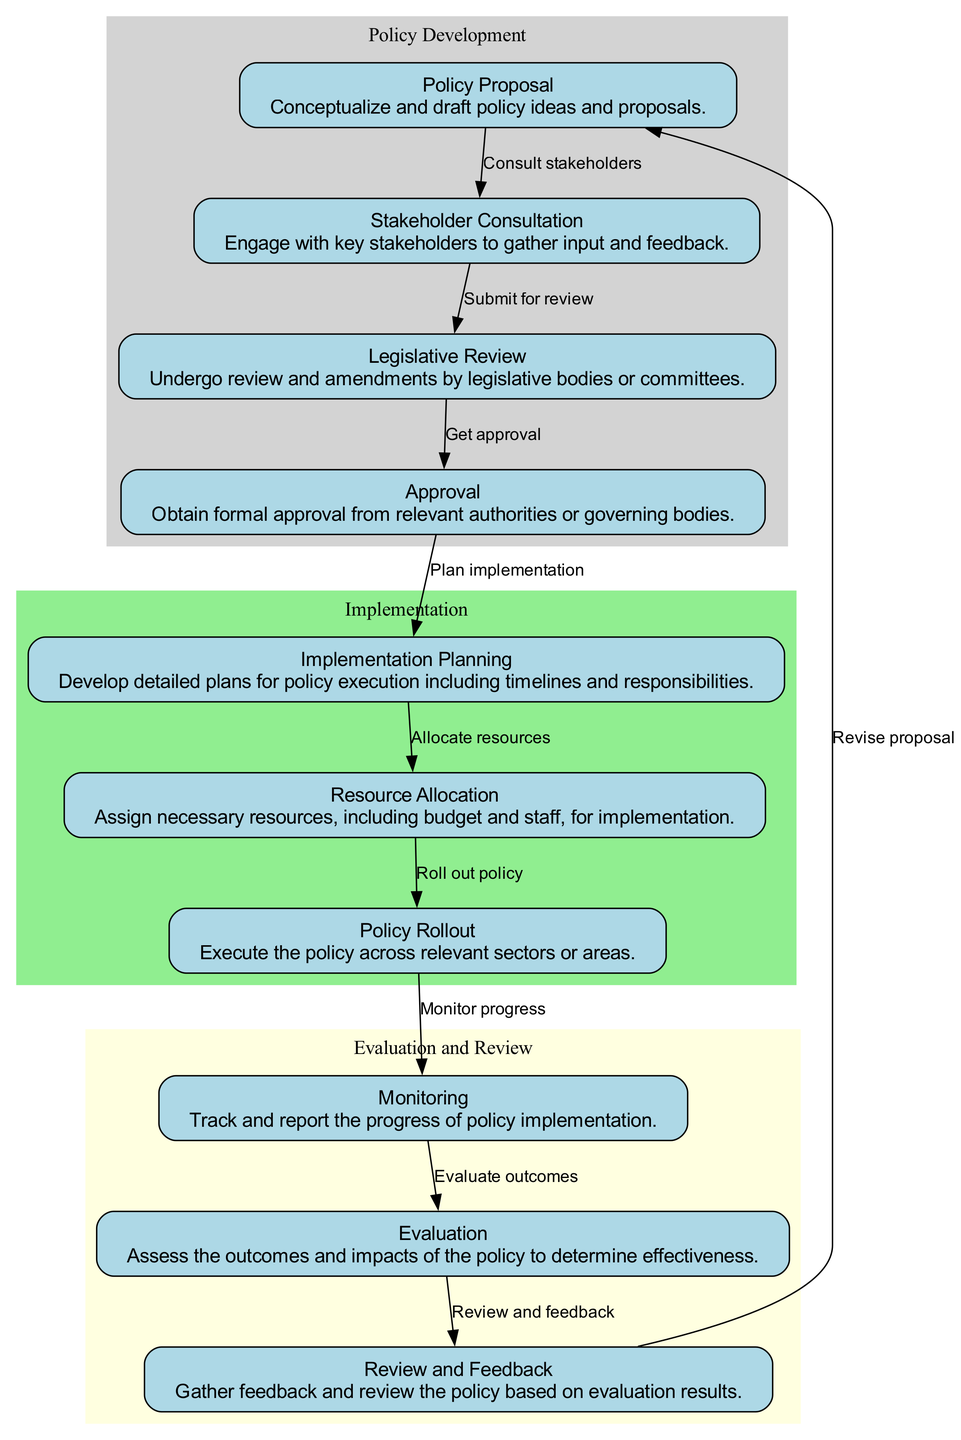What is the first step in the policy lifecycle? The first step in the policy lifecycle is represented by the node labeled "Policy Proposal." This is the starting point where policy ideas are created.
Answer: Policy Proposal How many nodes are in the diagram? The diagram includes a total of 10 nodes, each representing a different stage in the policy lifecycle from proposal to evaluation.
Answer: 10 What connects "Legislative Review" to "Approval"? "Legislative Review" is connected to "Approval" by an edge labeled "Get approval," indicating that following legislative review, formal approval is sought.
Answer: Get approval Which step comes after "Resource Allocation"? The step that follows "Resource Allocation" is "Policy Rollout," indicating that after resources are allocated, the policy is executed.
Answer: Policy Rollout What two nodes are connected by the edge labeled "Submit for review"? The edge labeled "Submit for review" connects the nodes "Stakeholder Consultation" and "Legislative Review," indicating the submission of the policy proposal for legislative examination.
Answer: Stakeholder Consultation and Legislative Review What phase includes both "Monitoring" and "Evaluation"? Both "Monitoring" and "Evaluation" are part of the "Evaluation and Review" phase, which focuses on assessing the policy's effectiveness.
Answer: Evaluation and Review How many edges are there in the diagram? There are a total of 9 edges that connect the different nodes in the policy lifecycle, representing the flow from one step to another.
Answer: 9 Which node comes before "Implementation Planning"? The node that comes before "Implementation Planning" is "Approval," indicating that formal approval must be obtained before planning for implementation can start.
Answer: Approval What is the relationship between "Review and Feedback" and "Policy Proposal"? "Review and Feedback" is connected back to "Policy Proposal" by the edge labeled "Revise proposal," indicating an iterative process where feedback leads to proposal revisions.
Answer: Revise proposal What is the last step in the policy lifecycle? The last step in the policy lifecycle is "Review and Feedback," where the policy is reviewed based on its evaluation results.
Answer: Review and Feedback 